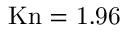Convert formula to latex. <formula><loc_0><loc_0><loc_500><loc_500>{ K n = 1 . 9 6 }</formula> 